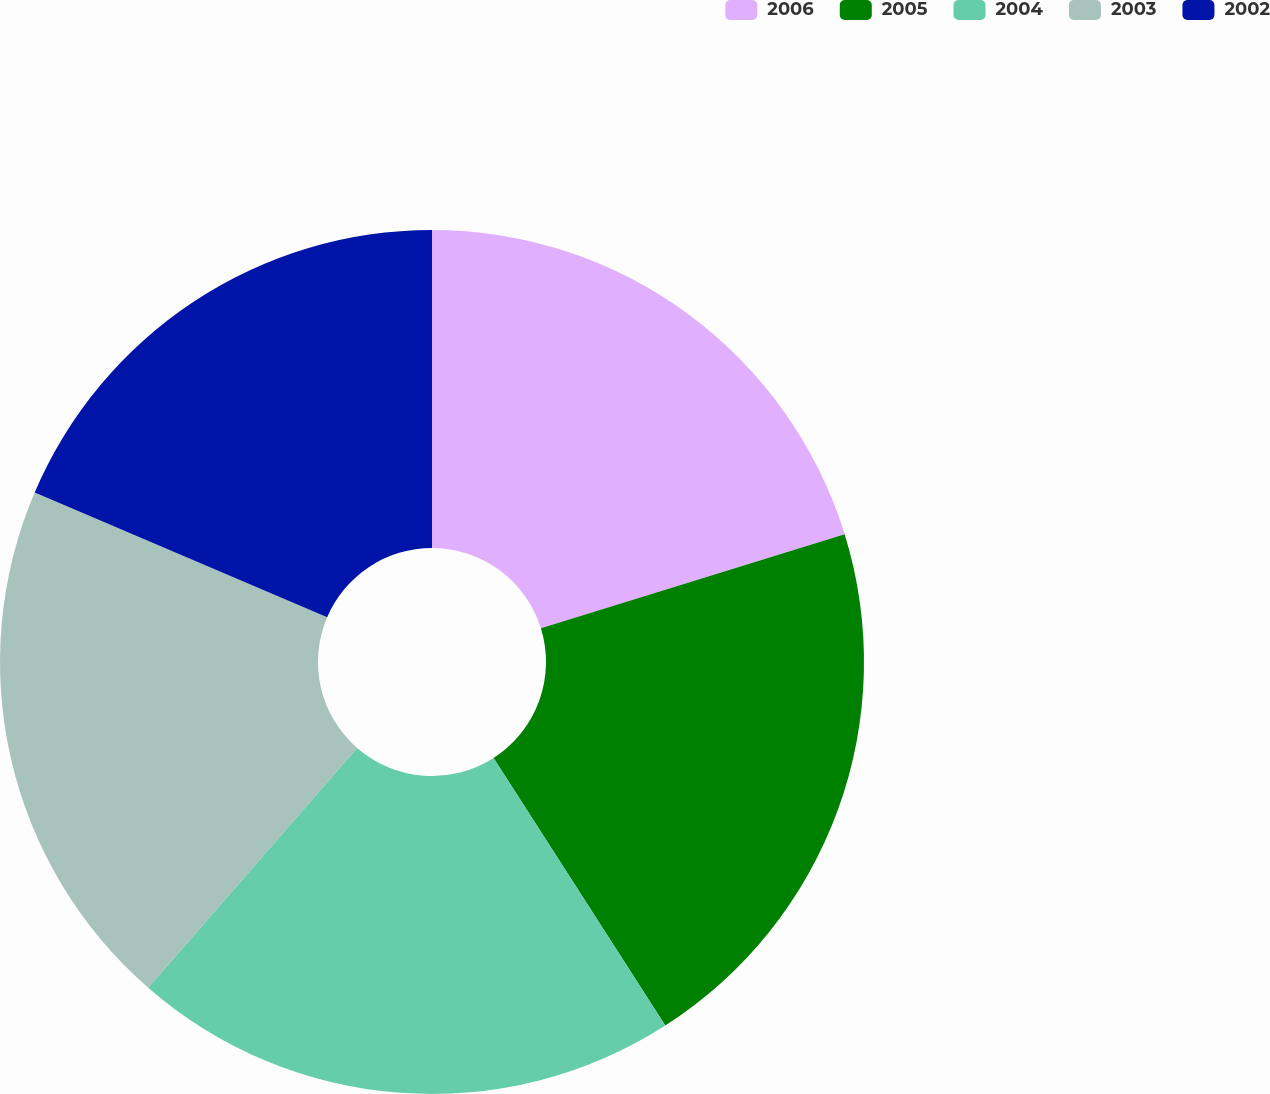<chart> <loc_0><loc_0><loc_500><loc_500><pie_chart><fcel>2006<fcel>2005<fcel>2004<fcel>2003<fcel>2002<nl><fcel>20.22%<fcel>20.7%<fcel>20.49%<fcel>20.01%<fcel>18.58%<nl></chart> 